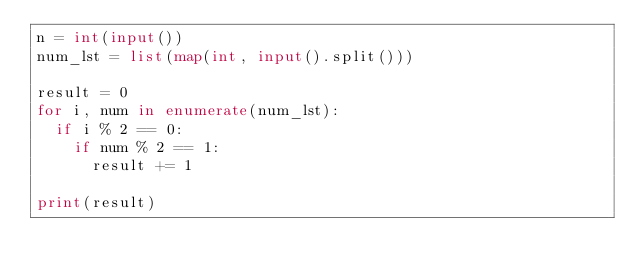Convert code to text. <code><loc_0><loc_0><loc_500><loc_500><_Python_>n = int(input())
num_lst = list(map(int, input().split()))

result = 0
for i, num in enumerate(num_lst):
  if i % 2 == 0:
    if num % 2 == 1:
      result += 1

print(result)</code> 